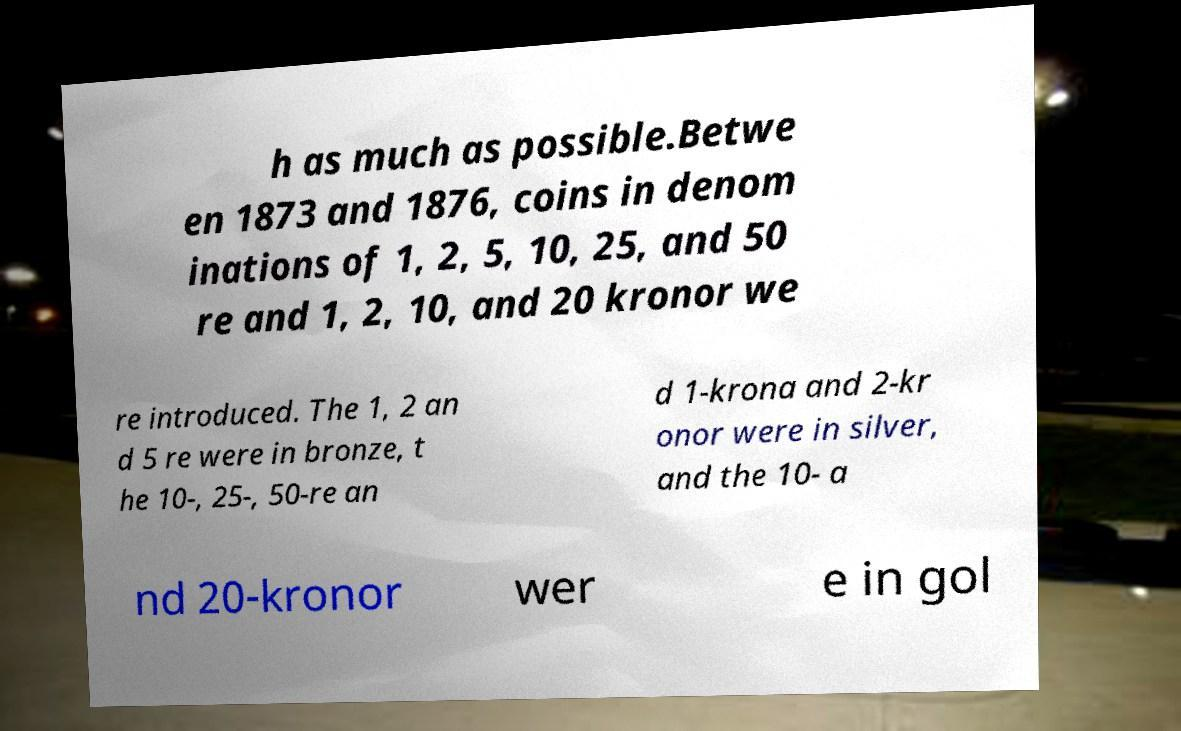Please identify and transcribe the text found in this image. h as much as possible.Betwe en 1873 and 1876, coins in denom inations of 1, 2, 5, 10, 25, and 50 re and 1, 2, 10, and 20 kronor we re introduced. The 1, 2 an d 5 re were in bronze, t he 10-, 25-, 50-re an d 1-krona and 2-kr onor were in silver, and the 10- a nd 20-kronor wer e in gol 